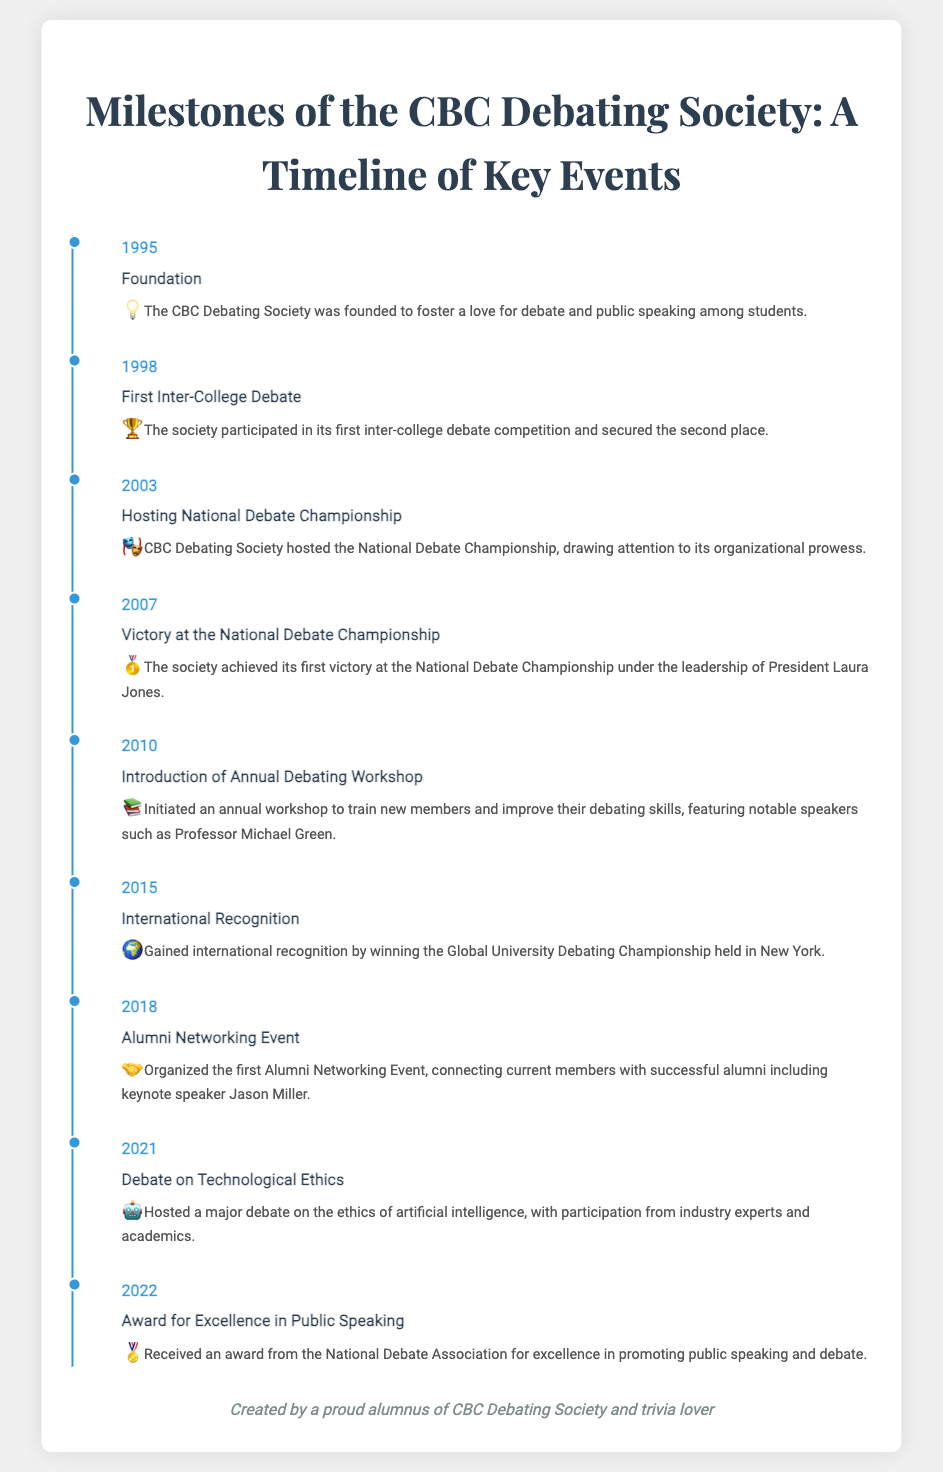What year was the CBC Debating Society founded? The founding year is explicitly stated as 1995 in the timeline.
Answer: 1995 What event did the CBC Debating Society achieve its first victory? The document mentions the "Victory at the National Debate Championship" as the first victory.
Answer: National Debate Championship Who was the president during the first victory at the National Debate Championship? It is mentioned in the timeline that Laura Jones was the president during the victory in 2007.
Answer: Laura Jones In what year did the CBC Debating Society gain international recognition? The timeline specifies the year 2015 for gaining international recognition.
Answer: 2015 What significant event took place in 2018? The timeline states that the "Alumni Networking Event" was organized in 2018.
Answer: Alumni Networking Event What was the award received in 2022? The document refers to an "Award for Excellence in Public Speaking" received in 2022.
Answer: Award for Excellence in Public Speaking What notable figure spoke at the annual debating workshop introduced in 2010? The timeline highlights Professor Michael Green as a notable speaker at the workshop.
Answer: Professor Michael Green What main topic was debated in 2021? The document indicates that the major debate in 2021 was about "Technological Ethics."
Answer: Technological Ethics What is the purpose of the CBC Debating Society? The founding purpose is described as fostering a love for debate and public speaking among students.
Answer: Foster a love for debate and public speaking 